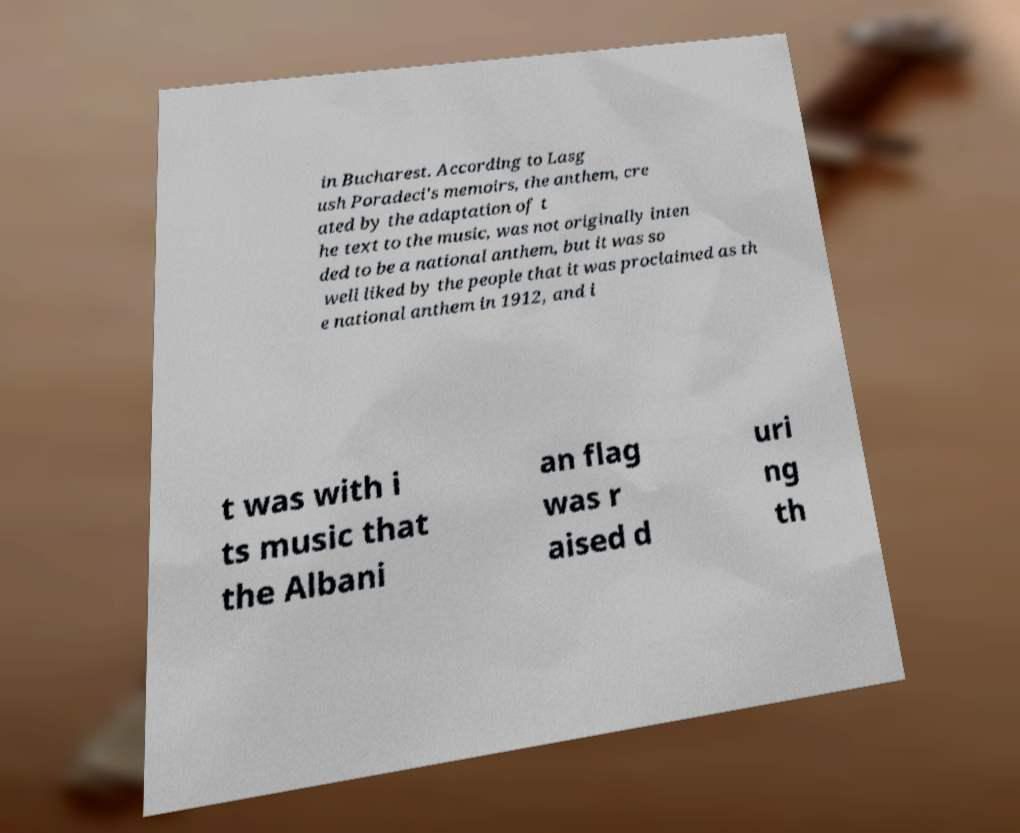Could you assist in decoding the text presented in this image and type it out clearly? in Bucharest. According to Lasg ush Poradeci's memoirs, the anthem, cre ated by the adaptation of t he text to the music, was not originally inten ded to be a national anthem, but it was so well liked by the people that it was proclaimed as th e national anthem in 1912, and i t was with i ts music that the Albani an flag was r aised d uri ng th 